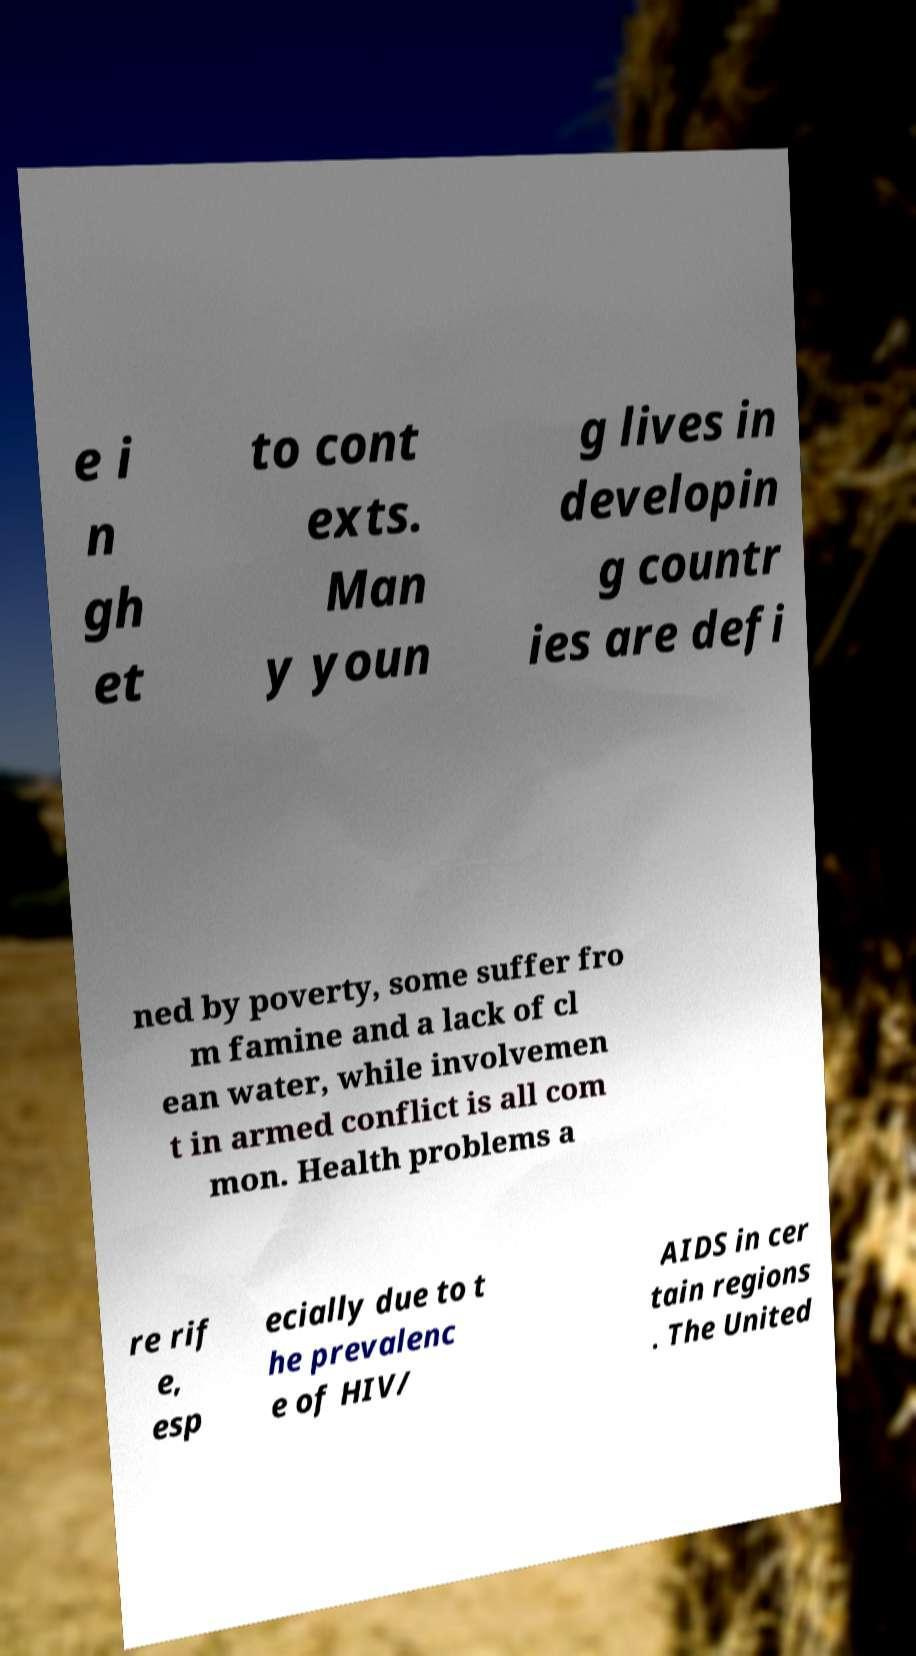Please identify and transcribe the text found in this image. e i n gh et to cont exts. Man y youn g lives in developin g countr ies are defi ned by poverty, some suffer fro m famine and a lack of cl ean water, while involvemen t in armed conflict is all com mon. Health problems a re rif e, esp ecially due to t he prevalenc e of HIV/ AIDS in cer tain regions . The United 